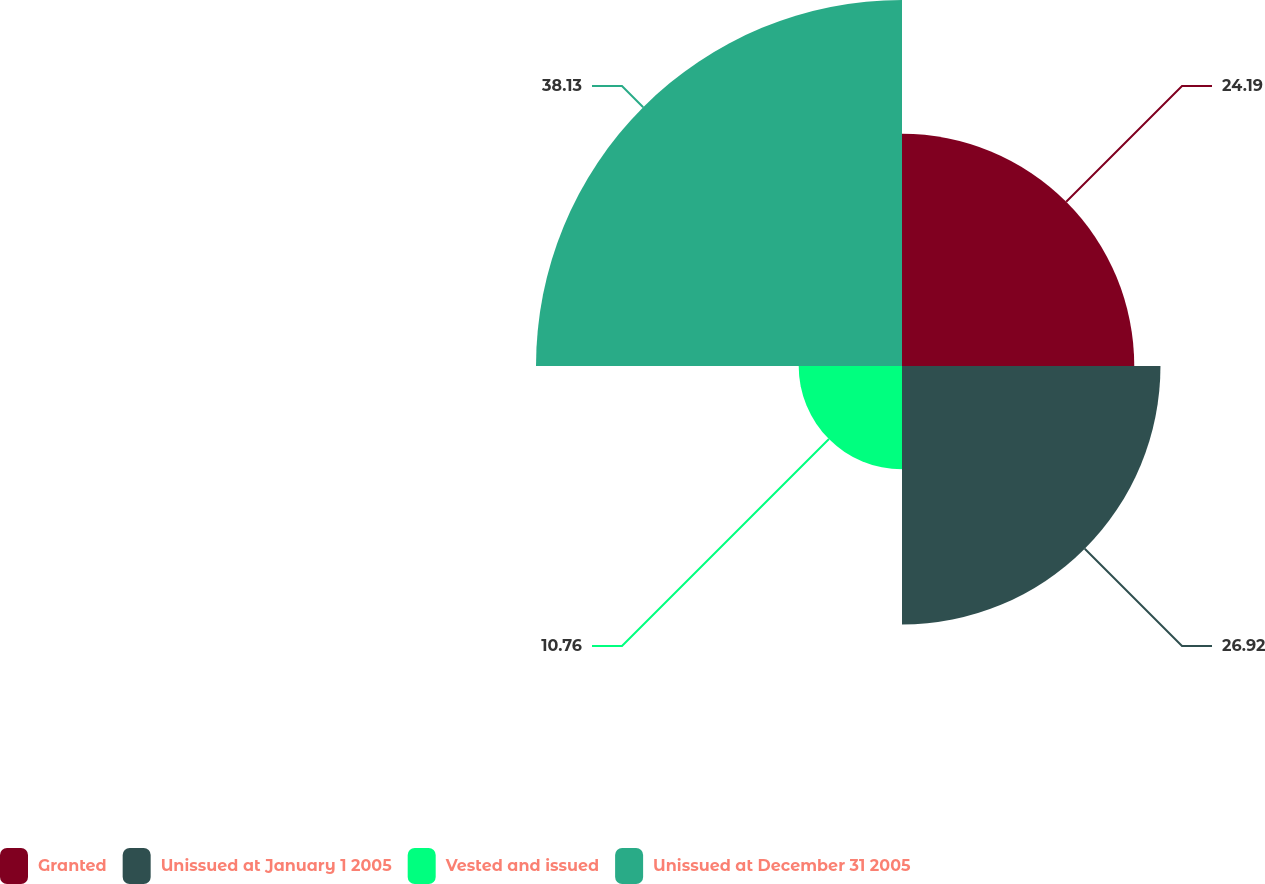Convert chart to OTSL. <chart><loc_0><loc_0><loc_500><loc_500><pie_chart><fcel>Granted<fcel>Unissued at January 1 2005<fcel>Vested and issued<fcel>Unissued at December 31 2005<nl><fcel>24.19%<fcel>26.92%<fcel>10.76%<fcel>38.12%<nl></chart> 